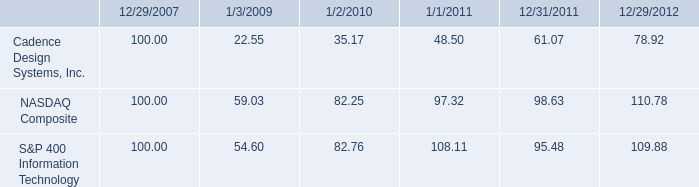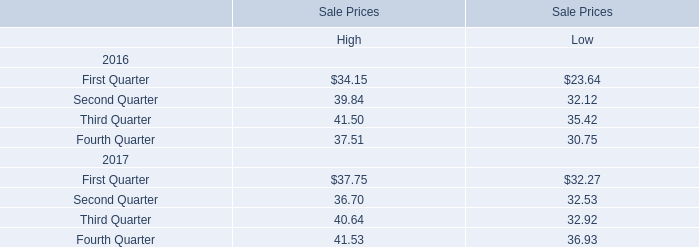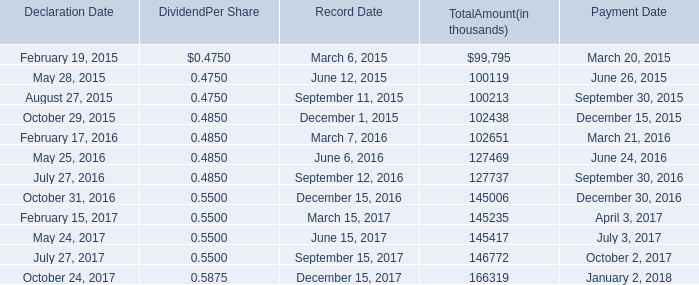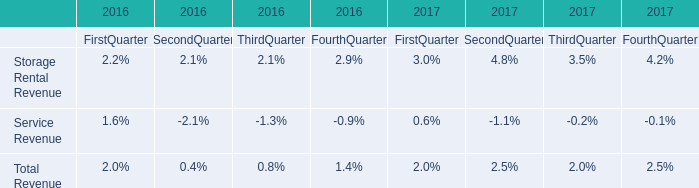what was the percentage cumulative 5-year total stockholder return for cadence design systems inc . for the five years ended 12/29/2012? 
Computations: ((78.92 - 100) / 100)
Answer: -0.2108. 